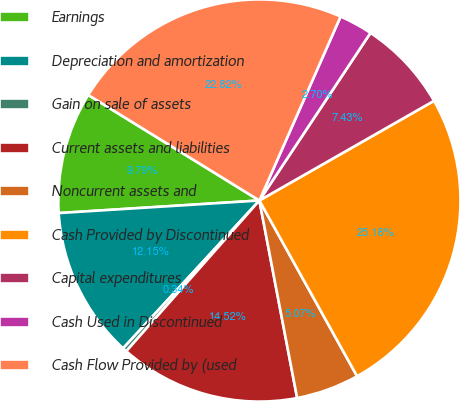<chart> <loc_0><loc_0><loc_500><loc_500><pie_chart><fcel>Earnings<fcel>Depreciation and amortization<fcel>Gain on sale of assets<fcel>Current assets and liabilities<fcel>Noncurrent assets and<fcel>Cash Provided by Discontinued<fcel>Capital expenditures<fcel>Cash Used in Discontinued<fcel>Cash Flow Provided by (used<nl><fcel>9.79%<fcel>12.15%<fcel>0.34%<fcel>14.52%<fcel>5.07%<fcel>25.18%<fcel>7.43%<fcel>2.7%<fcel>22.82%<nl></chart> 